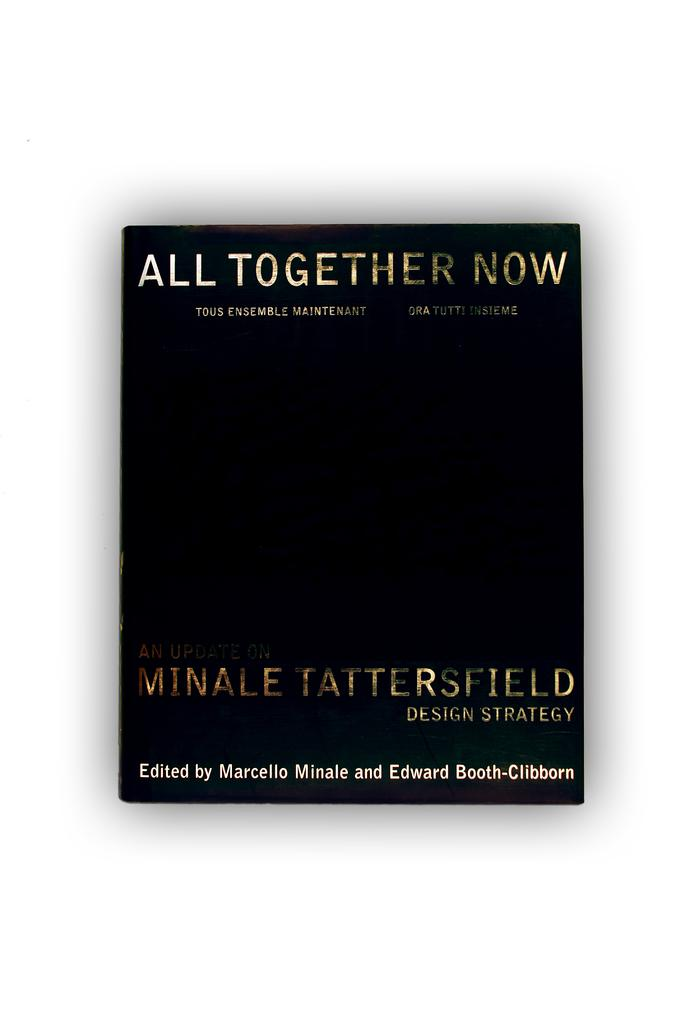<image>
Summarize the visual content of the image. black book with title all together now edited by marcello minale and edward booth-clibborn 